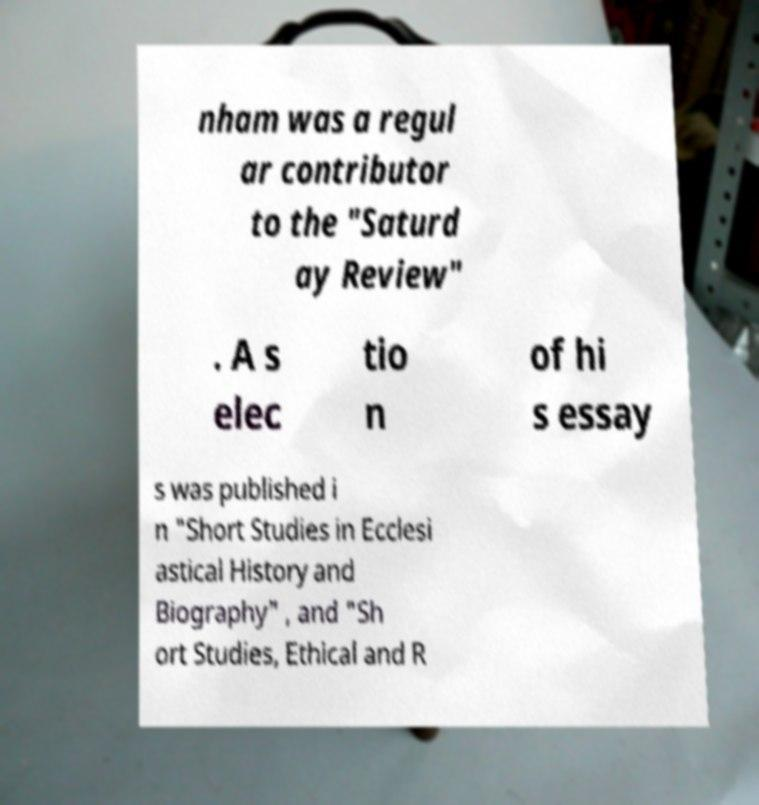Please read and relay the text visible in this image. What does it say? nham was a regul ar contributor to the "Saturd ay Review" . A s elec tio n of hi s essay s was published i n "Short Studies in Ecclesi astical History and Biography" , and "Sh ort Studies, Ethical and R 